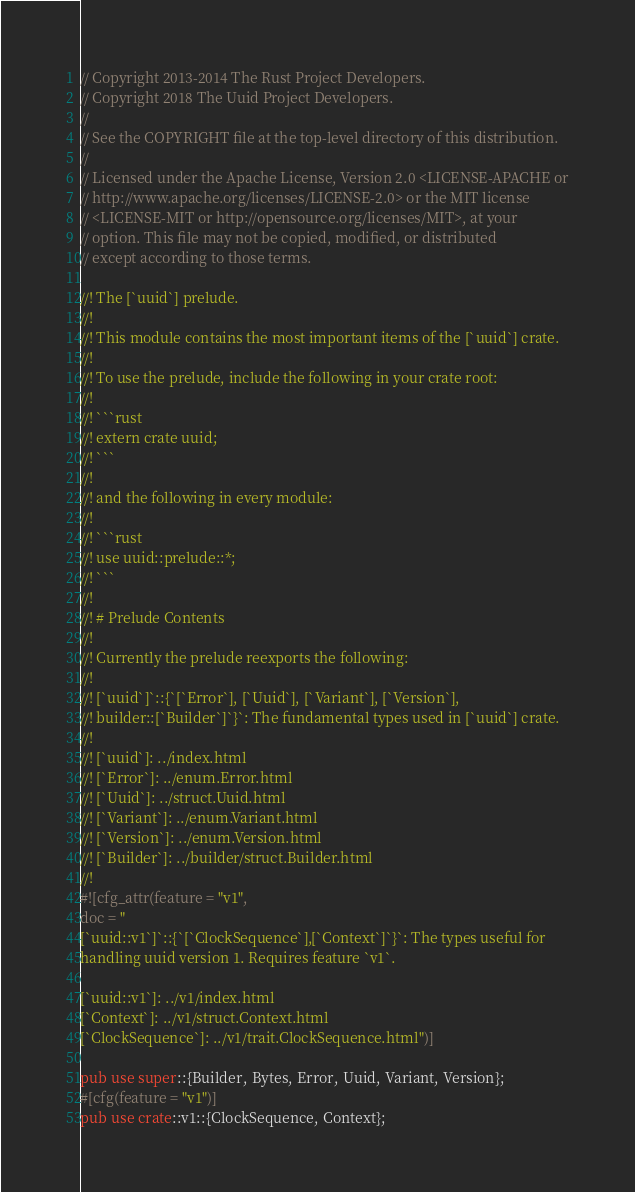<code> <loc_0><loc_0><loc_500><loc_500><_Rust_>// Copyright 2013-2014 The Rust Project Developers.
// Copyright 2018 The Uuid Project Developers.
//
// See the COPYRIGHT file at the top-level directory of this distribution.
//
// Licensed under the Apache License, Version 2.0 <LICENSE-APACHE or
// http://www.apache.org/licenses/LICENSE-2.0> or the MIT license
// <LICENSE-MIT or http://opensource.org/licenses/MIT>, at your
// option. This file may not be copied, modified, or distributed
// except according to those terms.

//! The [`uuid`] prelude.
//!
//! This module contains the most important items of the [`uuid`] crate.
//!
//! To use the prelude, include the following in your crate root:
//!
//! ```rust
//! extern crate uuid;
//! ```
//!
//! and the following in every module:
//!
//! ```rust
//! use uuid::prelude::*;
//! ```
//!
//! # Prelude Contents
//!
//! Currently the prelude reexports the following:
//!
//! [`uuid`]`::{`[`Error`], [`Uuid`], [`Variant`], [`Version`],
//! builder::[`Builder`]`}`: The fundamental types used in [`uuid`] crate.
//!
//! [`uuid`]: ../index.html
//! [`Error`]: ../enum.Error.html
//! [`Uuid`]: ../struct.Uuid.html
//! [`Variant`]: ../enum.Variant.html
//! [`Version`]: ../enum.Version.html
//! [`Builder`]: ../builder/struct.Builder.html
//!
#![cfg_attr(feature = "v1",
doc = "
[`uuid::v1`]`::{`[`ClockSequence`],[`Context`]`}`: The types useful for
handling uuid version 1. Requires feature `v1`.

[`uuid::v1`]: ../v1/index.html
[`Context`]: ../v1/struct.Context.html
[`ClockSequence`]: ../v1/trait.ClockSequence.html")]

pub use super::{Builder, Bytes, Error, Uuid, Variant, Version};
#[cfg(feature = "v1")]
pub use crate::v1::{ClockSequence, Context};
</code> 